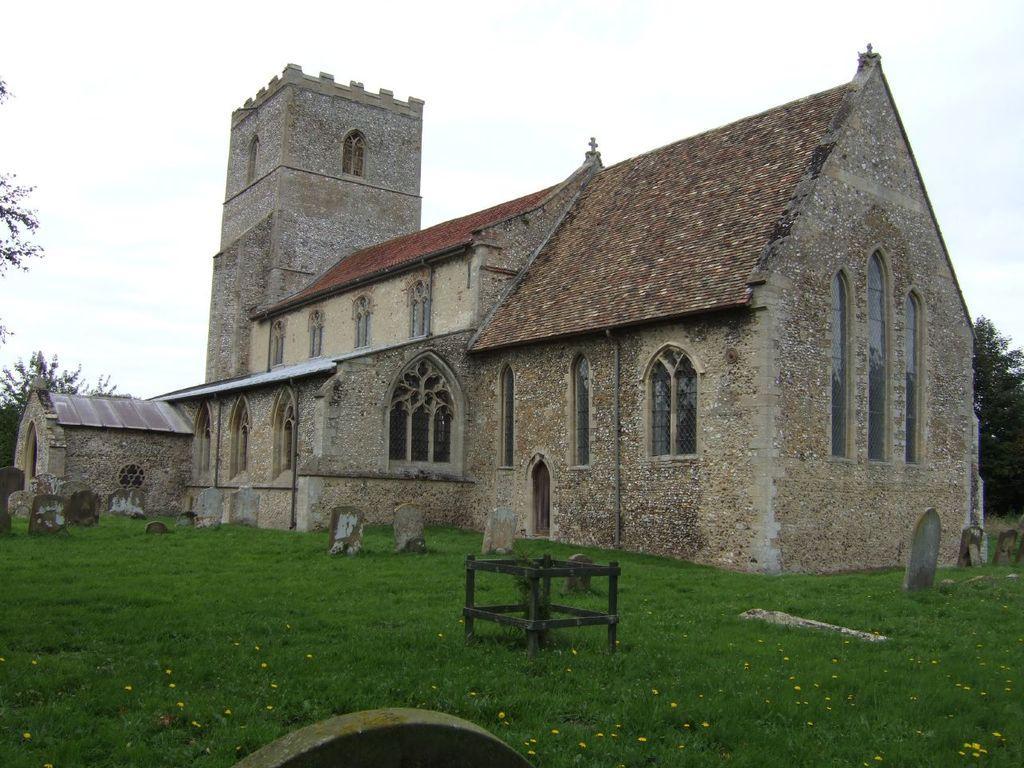Describe this image in one or two sentences. In this image there is a building, in front of the building there is a graveyard on the surface of the grass, there is a wooden structure. In the background there are trees and the sky. 